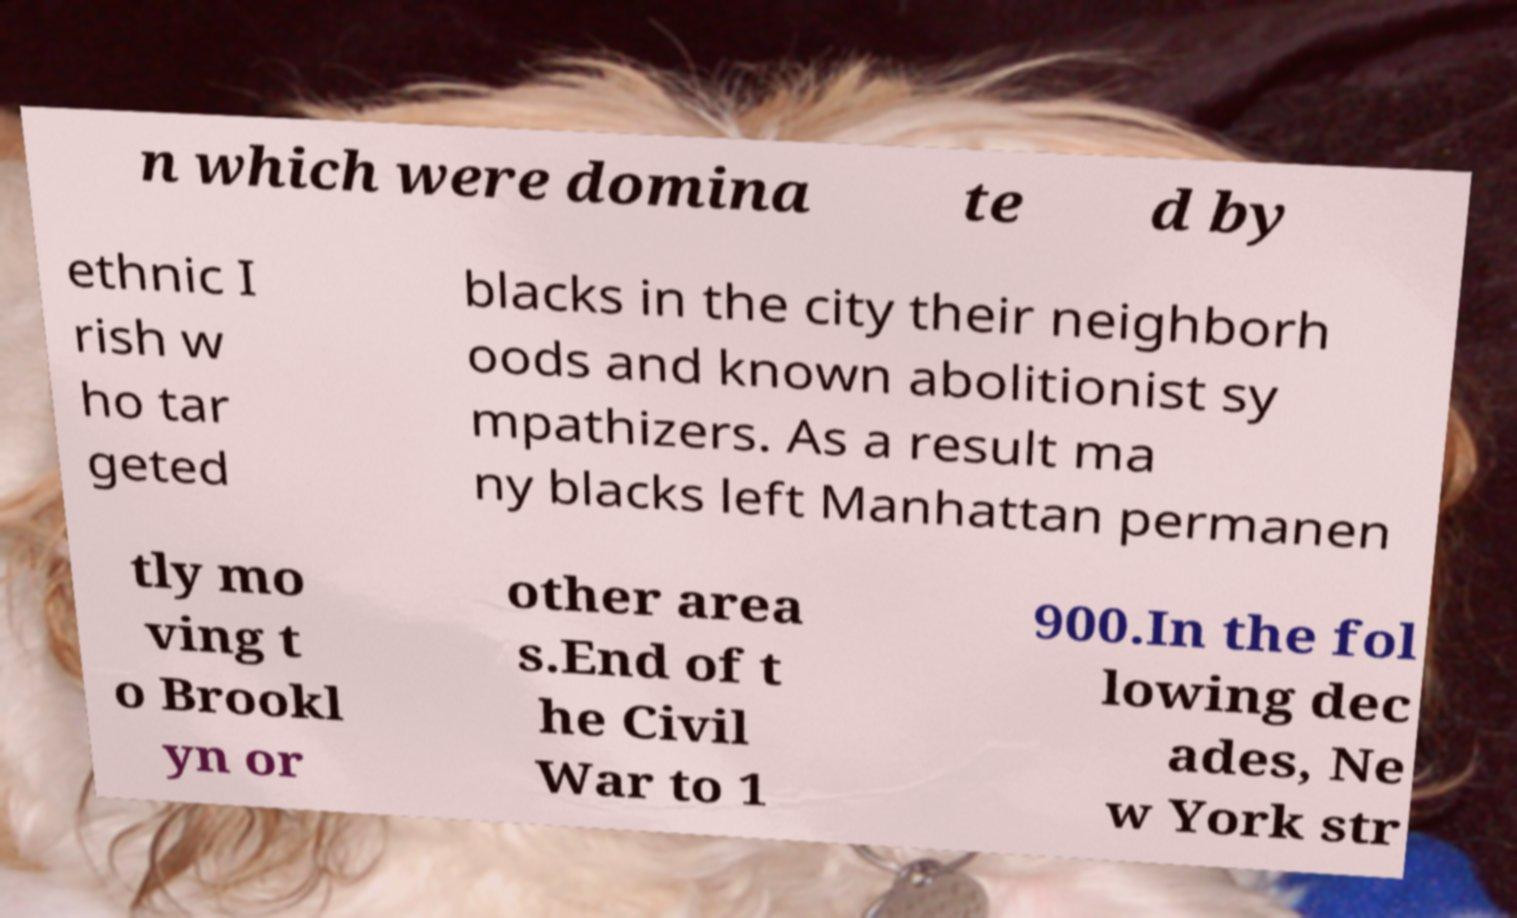Can you read and provide the text displayed in the image?This photo seems to have some interesting text. Can you extract and type it out for me? n which were domina te d by ethnic I rish w ho tar geted blacks in the city their neighborh oods and known abolitionist sy mpathizers. As a result ma ny blacks left Manhattan permanen tly mo ving t o Brookl yn or other area s.End of t he Civil War to 1 900.In the fol lowing dec ades, Ne w York str 